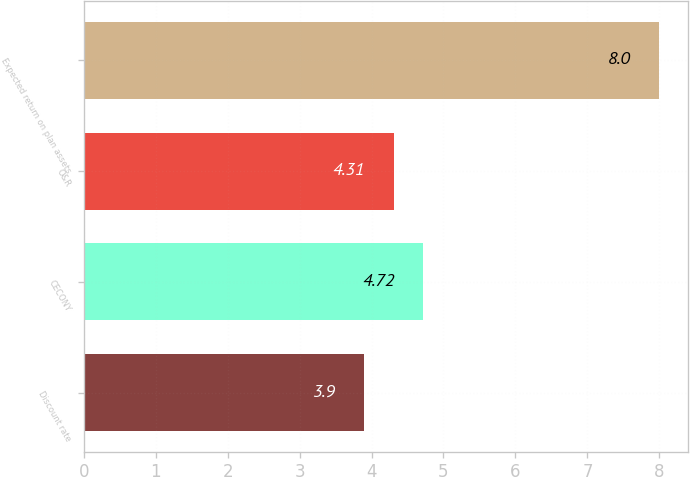Convert chart to OTSL. <chart><loc_0><loc_0><loc_500><loc_500><bar_chart><fcel>Discount rate<fcel>CECONY<fcel>O&R<fcel>Expected return on plan assets<nl><fcel>3.9<fcel>4.72<fcel>4.31<fcel>8<nl></chart> 